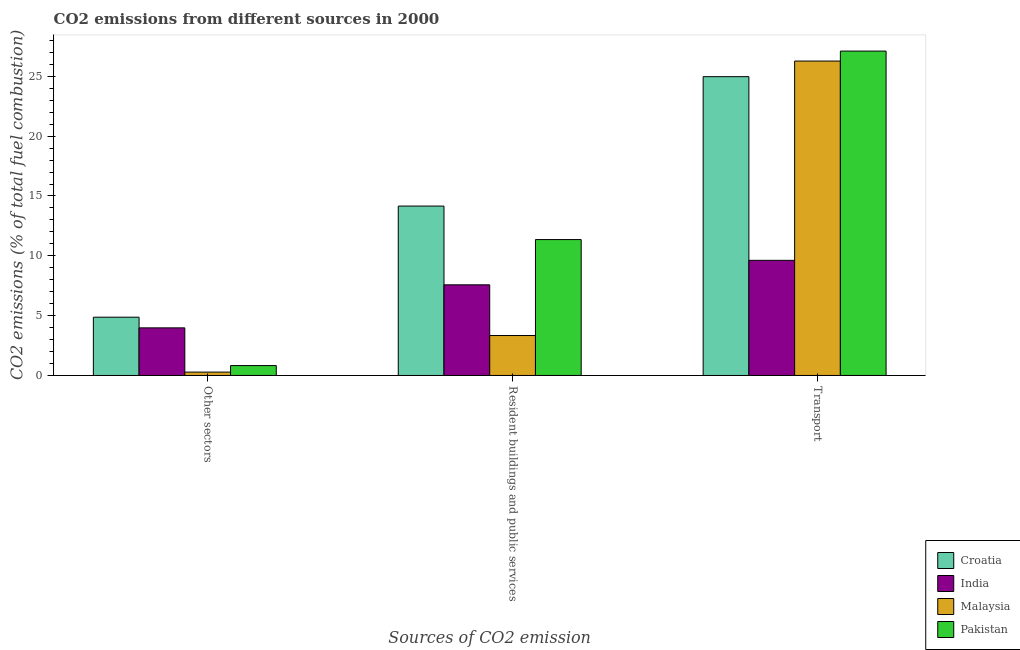How many groups of bars are there?
Ensure brevity in your answer.  3. Are the number of bars per tick equal to the number of legend labels?
Provide a succinct answer. Yes. How many bars are there on the 2nd tick from the left?
Your answer should be very brief. 4. What is the label of the 1st group of bars from the left?
Offer a very short reply. Other sectors. What is the percentage of co2 emissions from transport in Croatia?
Make the answer very short. 24.97. Across all countries, what is the maximum percentage of co2 emissions from transport?
Offer a very short reply. 27.11. Across all countries, what is the minimum percentage of co2 emissions from resident buildings and public services?
Provide a short and direct response. 3.34. In which country was the percentage of co2 emissions from transport maximum?
Offer a very short reply. Pakistan. What is the total percentage of co2 emissions from other sectors in the graph?
Make the answer very short. 9.95. What is the difference between the percentage of co2 emissions from other sectors in India and that in Pakistan?
Your answer should be compact. 3.15. What is the difference between the percentage of co2 emissions from other sectors in Malaysia and the percentage of co2 emissions from transport in Croatia?
Give a very brief answer. -24.69. What is the average percentage of co2 emissions from resident buildings and public services per country?
Offer a very short reply. 9.11. What is the difference between the percentage of co2 emissions from other sectors and percentage of co2 emissions from transport in Malaysia?
Offer a terse response. -26. What is the ratio of the percentage of co2 emissions from other sectors in Malaysia to that in India?
Provide a succinct answer. 0.07. What is the difference between the highest and the second highest percentage of co2 emissions from resident buildings and public services?
Your answer should be very brief. 2.8. What is the difference between the highest and the lowest percentage of co2 emissions from transport?
Your response must be concise. 17.49. Is the sum of the percentage of co2 emissions from transport in Malaysia and Pakistan greater than the maximum percentage of co2 emissions from other sectors across all countries?
Your answer should be very brief. Yes. What does the 3rd bar from the left in Resident buildings and public services represents?
Offer a terse response. Malaysia. What does the 1st bar from the right in Resident buildings and public services represents?
Make the answer very short. Pakistan. How many bars are there?
Provide a succinct answer. 12. Are all the bars in the graph horizontal?
Offer a very short reply. No. What is the difference between two consecutive major ticks on the Y-axis?
Ensure brevity in your answer.  5. Where does the legend appear in the graph?
Keep it short and to the point. Bottom right. How are the legend labels stacked?
Give a very brief answer. Vertical. What is the title of the graph?
Give a very brief answer. CO2 emissions from different sources in 2000. What is the label or title of the X-axis?
Offer a very short reply. Sources of CO2 emission. What is the label or title of the Y-axis?
Keep it short and to the point. CO2 emissions (% of total fuel combustion). What is the CO2 emissions (% of total fuel combustion) of Croatia in Other sectors?
Your answer should be very brief. 4.87. What is the CO2 emissions (% of total fuel combustion) of India in Other sectors?
Make the answer very short. 3.98. What is the CO2 emissions (% of total fuel combustion) in Malaysia in Other sectors?
Your answer should be compact. 0.28. What is the CO2 emissions (% of total fuel combustion) in Pakistan in Other sectors?
Make the answer very short. 0.83. What is the CO2 emissions (% of total fuel combustion) of Croatia in Resident buildings and public services?
Your response must be concise. 14.16. What is the CO2 emissions (% of total fuel combustion) of India in Resident buildings and public services?
Your answer should be compact. 7.58. What is the CO2 emissions (% of total fuel combustion) in Malaysia in Resident buildings and public services?
Provide a succinct answer. 3.34. What is the CO2 emissions (% of total fuel combustion) of Pakistan in Resident buildings and public services?
Your response must be concise. 11.36. What is the CO2 emissions (% of total fuel combustion) of Croatia in Transport?
Give a very brief answer. 24.97. What is the CO2 emissions (% of total fuel combustion) in India in Transport?
Make the answer very short. 9.62. What is the CO2 emissions (% of total fuel combustion) in Malaysia in Transport?
Offer a very short reply. 26.28. What is the CO2 emissions (% of total fuel combustion) of Pakistan in Transport?
Offer a very short reply. 27.11. Across all Sources of CO2 emission, what is the maximum CO2 emissions (% of total fuel combustion) in Croatia?
Make the answer very short. 24.97. Across all Sources of CO2 emission, what is the maximum CO2 emissions (% of total fuel combustion) in India?
Your answer should be compact. 9.62. Across all Sources of CO2 emission, what is the maximum CO2 emissions (% of total fuel combustion) in Malaysia?
Give a very brief answer. 26.28. Across all Sources of CO2 emission, what is the maximum CO2 emissions (% of total fuel combustion) in Pakistan?
Your answer should be compact. 27.11. Across all Sources of CO2 emission, what is the minimum CO2 emissions (% of total fuel combustion) of Croatia?
Your answer should be compact. 4.87. Across all Sources of CO2 emission, what is the minimum CO2 emissions (% of total fuel combustion) of India?
Provide a short and direct response. 3.98. Across all Sources of CO2 emission, what is the minimum CO2 emissions (% of total fuel combustion) of Malaysia?
Offer a very short reply. 0.28. Across all Sources of CO2 emission, what is the minimum CO2 emissions (% of total fuel combustion) of Pakistan?
Offer a terse response. 0.83. What is the total CO2 emissions (% of total fuel combustion) in Croatia in the graph?
Give a very brief answer. 44. What is the total CO2 emissions (% of total fuel combustion) of India in the graph?
Offer a very short reply. 21.18. What is the total CO2 emissions (% of total fuel combustion) in Malaysia in the graph?
Your answer should be compact. 29.89. What is the total CO2 emissions (% of total fuel combustion) in Pakistan in the graph?
Make the answer very short. 39.29. What is the difference between the CO2 emissions (% of total fuel combustion) of Croatia in Other sectors and that in Resident buildings and public services?
Your answer should be very brief. -9.29. What is the difference between the CO2 emissions (% of total fuel combustion) of India in Other sectors and that in Resident buildings and public services?
Ensure brevity in your answer.  -3.6. What is the difference between the CO2 emissions (% of total fuel combustion) of Malaysia in Other sectors and that in Resident buildings and public services?
Your answer should be very brief. -3.06. What is the difference between the CO2 emissions (% of total fuel combustion) of Pakistan in Other sectors and that in Resident buildings and public services?
Give a very brief answer. -10.53. What is the difference between the CO2 emissions (% of total fuel combustion) of Croatia in Other sectors and that in Transport?
Make the answer very short. -20.1. What is the difference between the CO2 emissions (% of total fuel combustion) in India in Other sectors and that in Transport?
Give a very brief answer. -5.64. What is the difference between the CO2 emissions (% of total fuel combustion) in Malaysia in Other sectors and that in Transport?
Make the answer very short. -26. What is the difference between the CO2 emissions (% of total fuel combustion) of Pakistan in Other sectors and that in Transport?
Keep it short and to the point. -26.28. What is the difference between the CO2 emissions (% of total fuel combustion) of Croatia in Resident buildings and public services and that in Transport?
Provide a short and direct response. -10.82. What is the difference between the CO2 emissions (% of total fuel combustion) of India in Resident buildings and public services and that in Transport?
Provide a succinct answer. -2.05. What is the difference between the CO2 emissions (% of total fuel combustion) in Malaysia in Resident buildings and public services and that in Transport?
Provide a short and direct response. -22.94. What is the difference between the CO2 emissions (% of total fuel combustion) of Pakistan in Resident buildings and public services and that in Transport?
Ensure brevity in your answer.  -15.75. What is the difference between the CO2 emissions (% of total fuel combustion) in Croatia in Other sectors and the CO2 emissions (% of total fuel combustion) in India in Resident buildings and public services?
Make the answer very short. -2.71. What is the difference between the CO2 emissions (% of total fuel combustion) in Croatia in Other sectors and the CO2 emissions (% of total fuel combustion) in Malaysia in Resident buildings and public services?
Give a very brief answer. 1.53. What is the difference between the CO2 emissions (% of total fuel combustion) of Croatia in Other sectors and the CO2 emissions (% of total fuel combustion) of Pakistan in Resident buildings and public services?
Your answer should be compact. -6.49. What is the difference between the CO2 emissions (% of total fuel combustion) in India in Other sectors and the CO2 emissions (% of total fuel combustion) in Malaysia in Resident buildings and public services?
Keep it short and to the point. 0.64. What is the difference between the CO2 emissions (% of total fuel combustion) of India in Other sectors and the CO2 emissions (% of total fuel combustion) of Pakistan in Resident buildings and public services?
Offer a terse response. -7.38. What is the difference between the CO2 emissions (% of total fuel combustion) of Malaysia in Other sectors and the CO2 emissions (% of total fuel combustion) of Pakistan in Resident buildings and public services?
Offer a terse response. -11.08. What is the difference between the CO2 emissions (% of total fuel combustion) of Croatia in Other sectors and the CO2 emissions (% of total fuel combustion) of India in Transport?
Ensure brevity in your answer.  -4.75. What is the difference between the CO2 emissions (% of total fuel combustion) of Croatia in Other sectors and the CO2 emissions (% of total fuel combustion) of Malaysia in Transport?
Provide a short and direct response. -21.41. What is the difference between the CO2 emissions (% of total fuel combustion) of Croatia in Other sectors and the CO2 emissions (% of total fuel combustion) of Pakistan in Transport?
Offer a terse response. -22.24. What is the difference between the CO2 emissions (% of total fuel combustion) of India in Other sectors and the CO2 emissions (% of total fuel combustion) of Malaysia in Transport?
Offer a very short reply. -22.3. What is the difference between the CO2 emissions (% of total fuel combustion) in India in Other sectors and the CO2 emissions (% of total fuel combustion) in Pakistan in Transport?
Provide a succinct answer. -23.13. What is the difference between the CO2 emissions (% of total fuel combustion) of Malaysia in Other sectors and the CO2 emissions (% of total fuel combustion) of Pakistan in Transport?
Keep it short and to the point. -26.83. What is the difference between the CO2 emissions (% of total fuel combustion) of Croatia in Resident buildings and public services and the CO2 emissions (% of total fuel combustion) of India in Transport?
Offer a very short reply. 4.53. What is the difference between the CO2 emissions (% of total fuel combustion) of Croatia in Resident buildings and public services and the CO2 emissions (% of total fuel combustion) of Malaysia in Transport?
Make the answer very short. -12.12. What is the difference between the CO2 emissions (% of total fuel combustion) in Croatia in Resident buildings and public services and the CO2 emissions (% of total fuel combustion) in Pakistan in Transport?
Offer a terse response. -12.95. What is the difference between the CO2 emissions (% of total fuel combustion) of India in Resident buildings and public services and the CO2 emissions (% of total fuel combustion) of Malaysia in Transport?
Keep it short and to the point. -18.7. What is the difference between the CO2 emissions (% of total fuel combustion) in India in Resident buildings and public services and the CO2 emissions (% of total fuel combustion) in Pakistan in Transport?
Your response must be concise. -19.53. What is the difference between the CO2 emissions (% of total fuel combustion) in Malaysia in Resident buildings and public services and the CO2 emissions (% of total fuel combustion) in Pakistan in Transport?
Offer a very short reply. -23.77. What is the average CO2 emissions (% of total fuel combustion) of Croatia per Sources of CO2 emission?
Ensure brevity in your answer.  14.67. What is the average CO2 emissions (% of total fuel combustion) of India per Sources of CO2 emission?
Give a very brief answer. 7.06. What is the average CO2 emissions (% of total fuel combustion) of Malaysia per Sources of CO2 emission?
Your answer should be very brief. 9.96. What is the average CO2 emissions (% of total fuel combustion) in Pakistan per Sources of CO2 emission?
Offer a very short reply. 13.1. What is the difference between the CO2 emissions (% of total fuel combustion) of Croatia and CO2 emissions (% of total fuel combustion) of India in Other sectors?
Provide a short and direct response. 0.89. What is the difference between the CO2 emissions (% of total fuel combustion) in Croatia and CO2 emissions (% of total fuel combustion) in Malaysia in Other sectors?
Keep it short and to the point. 4.59. What is the difference between the CO2 emissions (% of total fuel combustion) of Croatia and CO2 emissions (% of total fuel combustion) of Pakistan in Other sectors?
Offer a very short reply. 4.04. What is the difference between the CO2 emissions (% of total fuel combustion) in India and CO2 emissions (% of total fuel combustion) in Malaysia in Other sectors?
Provide a succinct answer. 3.7. What is the difference between the CO2 emissions (% of total fuel combustion) in India and CO2 emissions (% of total fuel combustion) in Pakistan in Other sectors?
Your response must be concise. 3.15. What is the difference between the CO2 emissions (% of total fuel combustion) of Malaysia and CO2 emissions (% of total fuel combustion) of Pakistan in Other sectors?
Your answer should be compact. -0.55. What is the difference between the CO2 emissions (% of total fuel combustion) in Croatia and CO2 emissions (% of total fuel combustion) in India in Resident buildings and public services?
Give a very brief answer. 6.58. What is the difference between the CO2 emissions (% of total fuel combustion) of Croatia and CO2 emissions (% of total fuel combustion) of Malaysia in Resident buildings and public services?
Make the answer very short. 10.82. What is the difference between the CO2 emissions (% of total fuel combustion) of Croatia and CO2 emissions (% of total fuel combustion) of Pakistan in Resident buildings and public services?
Provide a succinct answer. 2.8. What is the difference between the CO2 emissions (% of total fuel combustion) in India and CO2 emissions (% of total fuel combustion) in Malaysia in Resident buildings and public services?
Your answer should be very brief. 4.24. What is the difference between the CO2 emissions (% of total fuel combustion) of India and CO2 emissions (% of total fuel combustion) of Pakistan in Resident buildings and public services?
Offer a terse response. -3.78. What is the difference between the CO2 emissions (% of total fuel combustion) of Malaysia and CO2 emissions (% of total fuel combustion) of Pakistan in Resident buildings and public services?
Provide a succinct answer. -8.02. What is the difference between the CO2 emissions (% of total fuel combustion) of Croatia and CO2 emissions (% of total fuel combustion) of India in Transport?
Offer a very short reply. 15.35. What is the difference between the CO2 emissions (% of total fuel combustion) of Croatia and CO2 emissions (% of total fuel combustion) of Malaysia in Transport?
Ensure brevity in your answer.  -1.3. What is the difference between the CO2 emissions (% of total fuel combustion) in Croatia and CO2 emissions (% of total fuel combustion) in Pakistan in Transport?
Offer a very short reply. -2.14. What is the difference between the CO2 emissions (% of total fuel combustion) in India and CO2 emissions (% of total fuel combustion) in Malaysia in Transport?
Offer a very short reply. -16.65. What is the difference between the CO2 emissions (% of total fuel combustion) of India and CO2 emissions (% of total fuel combustion) of Pakistan in Transport?
Ensure brevity in your answer.  -17.49. What is the difference between the CO2 emissions (% of total fuel combustion) of Malaysia and CO2 emissions (% of total fuel combustion) of Pakistan in Transport?
Provide a succinct answer. -0.83. What is the ratio of the CO2 emissions (% of total fuel combustion) of Croatia in Other sectors to that in Resident buildings and public services?
Offer a terse response. 0.34. What is the ratio of the CO2 emissions (% of total fuel combustion) in India in Other sectors to that in Resident buildings and public services?
Offer a terse response. 0.53. What is the ratio of the CO2 emissions (% of total fuel combustion) in Malaysia in Other sectors to that in Resident buildings and public services?
Keep it short and to the point. 0.08. What is the ratio of the CO2 emissions (% of total fuel combustion) in Pakistan in Other sectors to that in Resident buildings and public services?
Provide a succinct answer. 0.07. What is the ratio of the CO2 emissions (% of total fuel combustion) in Croatia in Other sectors to that in Transport?
Keep it short and to the point. 0.2. What is the ratio of the CO2 emissions (% of total fuel combustion) in India in Other sectors to that in Transport?
Offer a terse response. 0.41. What is the ratio of the CO2 emissions (% of total fuel combustion) in Malaysia in Other sectors to that in Transport?
Ensure brevity in your answer.  0.01. What is the ratio of the CO2 emissions (% of total fuel combustion) of Pakistan in Other sectors to that in Transport?
Provide a short and direct response. 0.03. What is the ratio of the CO2 emissions (% of total fuel combustion) of Croatia in Resident buildings and public services to that in Transport?
Make the answer very short. 0.57. What is the ratio of the CO2 emissions (% of total fuel combustion) of India in Resident buildings and public services to that in Transport?
Ensure brevity in your answer.  0.79. What is the ratio of the CO2 emissions (% of total fuel combustion) of Malaysia in Resident buildings and public services to that in Transport?
Ensure brevity in your answer.  0.13. What is the ratio of the CO2 emissions (% of total fuel combustion) of Pakistan in Resident buildings and public services to that in Transport?
Keep it short and to the point. 0.42. What is the difference between the highest and the second highest CO2 emissions (% of total fuel combustion) of Croatia?
Make the answer very short. 10.82. What is the difference between the highest and the second highest CO2 emissions (% of total fuel combustion) of India?
Make the answer very short. 2.05. What is the difference between the highest and the second highest CO2 emissions (% of total fuel combustion) in Malaysia?
Your answer should be compact. 22.94. What is the difference between the highest and the second highest CO2 emissions (% of total fuel combustion) in Pakistan?
Ensure brevity in your answer.  15.75. What is the difference between the highest and the lowest CO2 emissions (% of total fuel combustion) in Croatia?
Your response must be concise. 20.1. What is the difference between the highest and the lowest CO2 emissions (% of total fuel combustion) of India?
Offer a very short reply. 5.64. What is the difference between the highest and the lowest CO2 emissions (% of total fuel combustion) in Malaysia?
Give a very brief answer. 26. What is the difference between the highest and the lowest CO2 emissions (% of total fuel combustion) in Pakistan?
Provide a succinct answer. 26.28. 